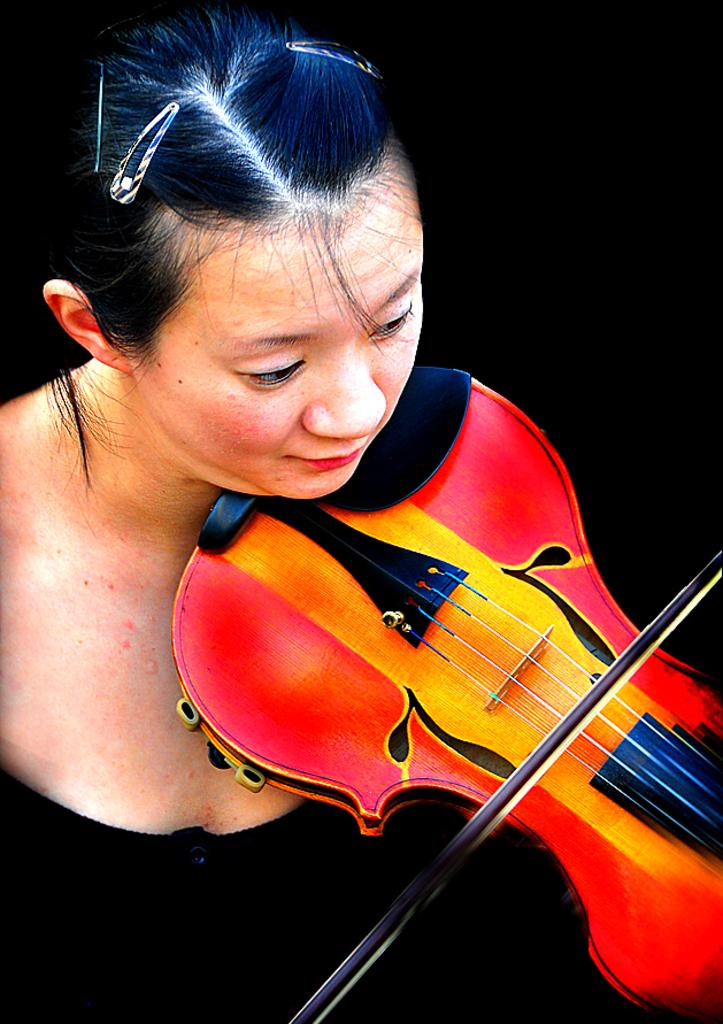Who is the main subject in the image? There is a lady in the image. What is the lady doing in the image? The lady is playing the violin. What is the reason the lady's toe is wiggling in the image? There is no indication in the image that the lady's toe is wiggling, and therefore no reason can be provided. 